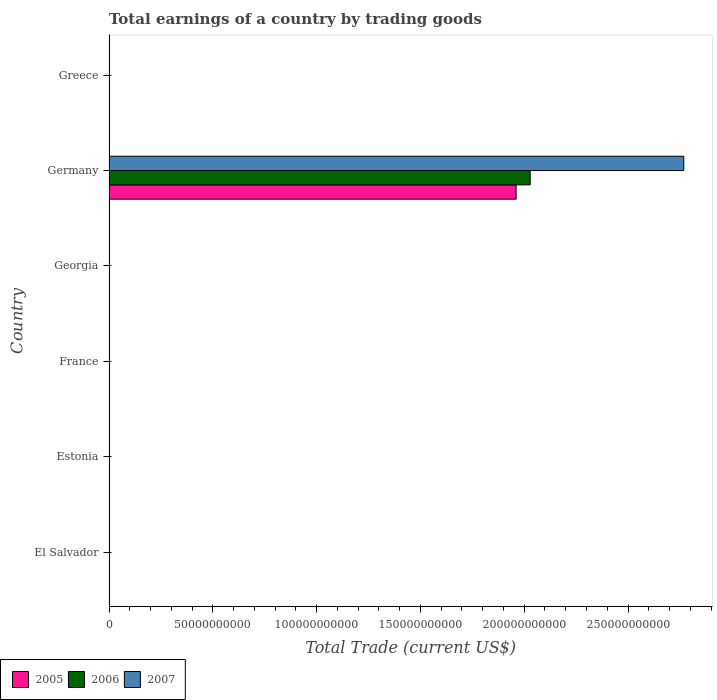How many different coloured bars are there?
Make the answer very short. 3. Are the number of bars per tick equal to the number of legend labels?
Make the answer very short. No. Are the number of bars on each tick of the Y-axis equal?
Offer a terse response. No. How many bars are there on the 6th tick from the top?
Give a very brief answer. 0. What is the label of the 5th group of bars from the top?
Your response must be concise. Estonia. In how many cases, is the number of bars for a given country not equal to the number of legend labels?
Give a very brief answer. 5. Across all countries, what is the maximum total earnings in 2006?
Provide a succinct answer. 2.03e+11. In which country was the total earnings in 2005 maximum?
Make the answer very short. Germany. What is the total total earnings in 2006 in the graph?
Make the answer very short. 2.03e+11. What is the difference between the total earnings in 2007 in El Salvador and the total earnings in 2006 in Germany?
Provide a short and direct response. -2.03e+11. What is the average total earnings in 2006 per country?
Provide a succinct answer. 3.38e+1. What is the difference between the total earnings in 2005 and total earnings in 2006 in Germany?
Your response must be concise. -6.78e+09. In how many countries, is the total earnings in 2006 greater than 210000000000 US$?
Offer a very short reply. 0. What is the difference between the highest and the lowest total earnings in 2006?
Your response must be concise. 2.03e+11. How many countries are there in the graph?
Offer a terse response. 6. What is the difference between two consecutive major ticks on the X-axis?
Offer a very short reply. 5.00e+1. Are the values on the major ticks of X-axis written in scientific E-notation?
Offer a terse response. No. Does the graph contain any zero values?
Make the answer very short. Yes. Does the graph contain grids?
Provide a succinct answer. No. Where does the legend appear in the graph?
Offer a terse response. Bottom left. How many legend labels are there?
Offer a terse response. 3. What is the title of the graph?
Provide a short and direct response. Total earnings of a country by trading goods. What is the label or title of the X-axis?
Provide a succinct answer. Total Trade (current US$). What is the Total Trade (current US$) in 2007 in El Salvador?
Provide a short and direct response. 0. What is the Total Trade (current US$) in 2005 in Estonia?
Your answer should be compact. 0. What is the Total Trade (current US$) in 2006 in Estonia?
Make the answer very short. 0. What is the Total Trade (current US$) in 2006 in Georgia?
Your response must be concise. 0. What is the Total Trade (current US$) of 2007 in Georgia?
Your answer should be very brief. 0. What is the Total Trade (current US$) in 2005 in Germany?
Keep it short and to the point. 1.96e+11. What is the Total Trade (current US$) in 2006 in Germany?
Your answer should be compact. 2.03e+11. What is the Total Trade (current US$) in 2007 in Germany?
Offer a very short reply. 2.77e+11. What is the Total Trade (current US$) of 2005 in Greece?
Your response must be concise. 0. What is the Total Trade (current US$) in 2006 in Greece?
Keep it short and to the point. 0. What is the Total Trade (current US$) of 2007 in Greece?
Your answer should be compact. 0. Across all countries, what is the maximum Total Trade (current US$) in 2005?
Give a very brief answer. 1.96e+11. Across all countries, what is the maximum Total Trade (current US$) in 2006?
Your answer should be very brief. 2.03e+11. Across all countries, what is the maximum Total Trade (current US$) of 2007?
Your response must be concise. 2.77e+11. Across all countries, what is the minimum Total Trade (current US$) of 2005?
Make the answer very short. 0. Across all countries, what is the minimum Total Trade (current US$) in 2006?
Keep it short and to the point. 0. What is the total Total Trade (current US$) in 2005 in the graph?
Your answer should be compact. 1.96e+11. What is the total Total Trade (current US$) of 2006 in the graph?
Offer a terse response. 2.03e+11. What is the total Total Trade (current US$) of 2007 in the graph?
Offer a very short reply. 2.77e+11. What is the average Total Trade (current US$) in 2005 per country?
Ensure brevity in your answer.  3.27e+1. What is the average Total Trade (current US$) in 2006 per country?
Provide a short and direct response. 3.38e+1. What is the average Total Trade (current US$) in 2007 per country?
Keep it short and to the point. 4.61e+1. What is the difference between the Total Trade (current US$) in 2005 and Total Trade (current US$) in 2006 in Germany?
Your answer should be compact. -6.78e+09. What is the difference between the Total Trade (current US$) in 2005 and Total Trade (current US$) in 2007 in Germany?
Your answer should be compact. -8.08e+1. What is the difference between the Total Trade (current US$) in 2006 and Total Trade (current US$) in 2007 in Germany?
Your response must be concise. -7.40e+1. What is the difference between the highest and the lowest Total Trade (current US$) in 2005?
Give a very brief answer. 1.96e+11. What is the difference between the highest and the lowest Total Trade (current US$) in 2006?
Your answer should be compact. 2.03e+11. What is the difference between the highest and the lowest Total Trade (current US$) of 2007?
Offer a terse response. 2.77e+11. 